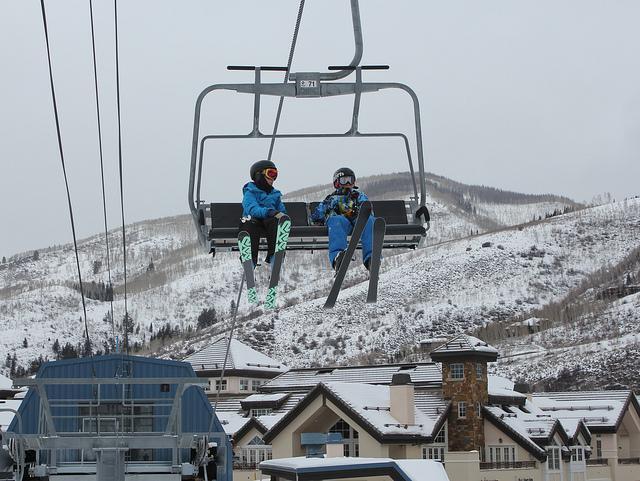How many people are in the carrier?
Give a very brief answer. 2. How many people are wearing hats?
Give a very brief answer. 2. How many people are on the lift?
Give a very brief answer. 2. How many people are visible?
Give a very brief answer. 2. How many big chairs are in the image?
Give a very brief answer. 0. 